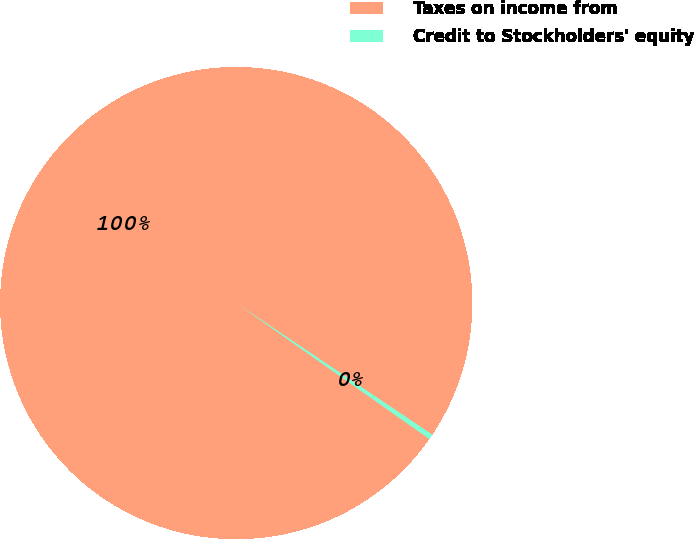<chart> <loc_0><loc_0><loc_500><loc_500><pie_chart><fcel>Taxes on income from<fcel>Credit to Stockholders' equity<nl><fcel>99.65%<fcel>0.35%<nl></chart> 